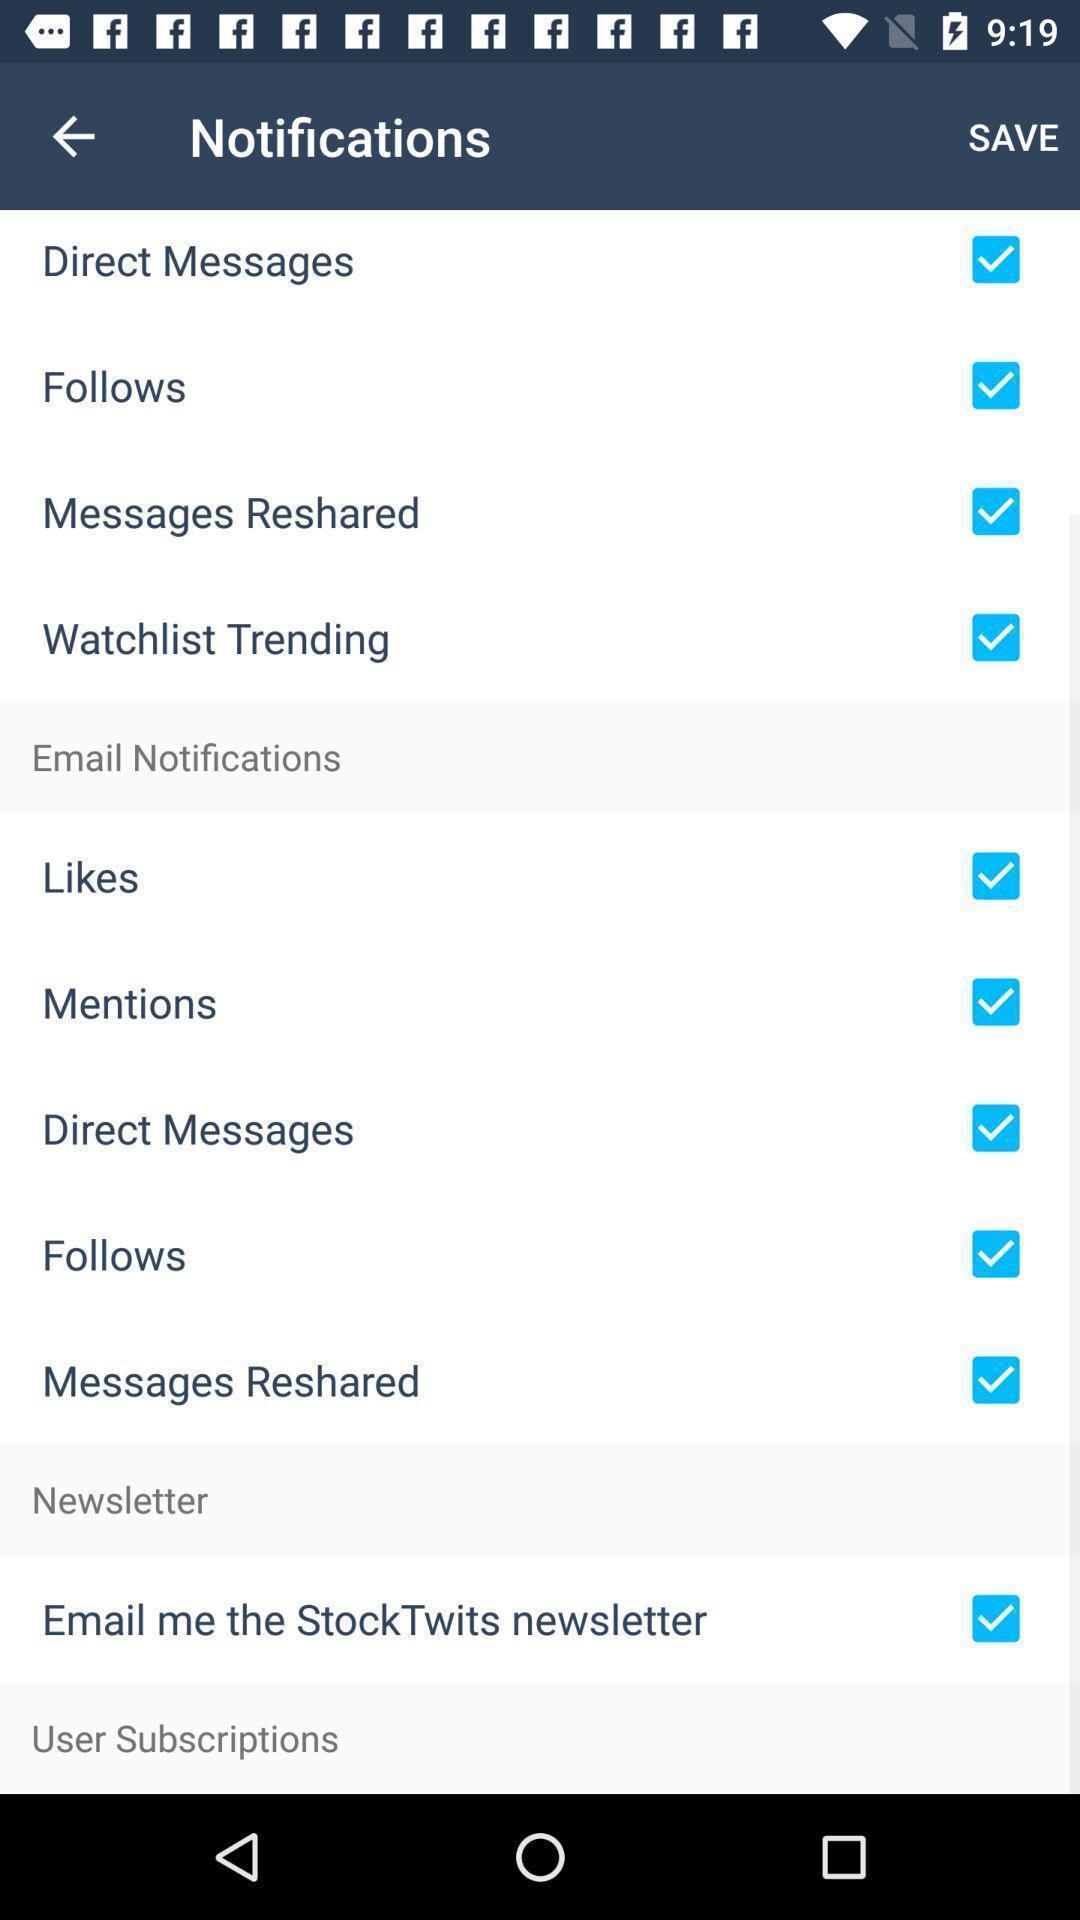Summarize the main components in this picture. Screen page displaying various options in settings application. 